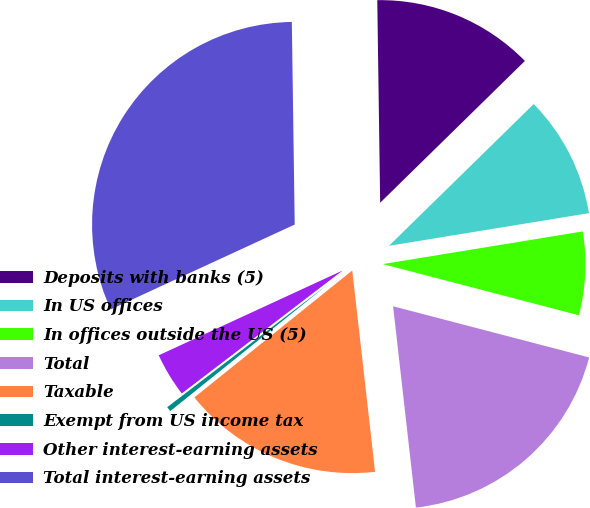Convert chart to OTSL. <chart><loc_0><loc_0><loc_500><loc_500><pie_chart><fcel>Deposits with banks (5)<fcel>In US offices<fcel>In offices outside the US (5)<fcel>Total<fcel>Taxable<fcel>Exempt from US income tax<fcel>Other interest-earning assets<fcel>Total interest-earning assets<nl><fcel>12.89%<fcel>9.76%<fcel>6.64%<fcel>19.14%<fcel>16.02%<fcel>0.39%<fcel>3.51%<fcel>31.65%<nl></chart> 